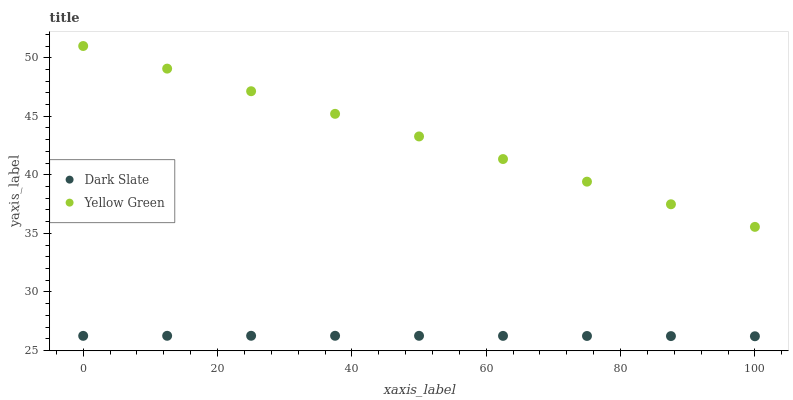Does Dark Slate have the minimum area under the curve?
Answer yes or no. Yes. Does Yellow Green have the maximum area under the curve?
Answer yes or no. Yes. Does Yellow Green have the minimum area under the curve?
Answer yes or no. No. Is Yellow Green the smoothest?
Answer yes or no. Yes. Is Dark Slate the roughest?
Answer yes or no. Yes. Is Yellow Green the roughest?
Answer yes or no. No. Does Dark Slate have the lowest value?
Answer yes or no. Yes. Does Yellow Green have the lowest value?
Answer yes or no. No. Does Yellow Green have the highest value?
Answer yes or no. Yes. Is Dark Slate less than Yellow Green?
Answer yes or no. Yes. Is Yellow Green greater than Dark Slate?
Answer yes or no. Yes. Does Dark Slate intersect Yellow Green?
Answer yes or no. No. 